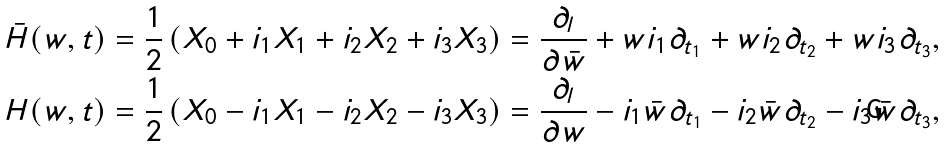<formula> <loc_0><loc_0><loc_500><loc_500>\bar { H } ( w , t ) & = \frac { 1 } { 2 } \left ( X _ { 0 } + i _ { 1 } X _ { 1 } + i _ { 2 } X _ { 2 } + i _ { 3 } X _ { 3 } \right ) = \frac { \partial _ { l } } { \partial \bar { w } } + w i _ { 1 } \partial _ { t _ { 1 } } + w i _ { 2 } \partial _ { t _ { 2 } } + w i _ { 3 } \partial _ { t _ { 3 } } , \\ H ( w , t ) & = \frac { 1 } { 2 } \left ( X _ { 0 } - i _ { 1 } X _ { 1 } - i _ { 2 } X _ { 2 } - i _ { 3 } X _ { 3 } \right ) = \frac { \partial _ { l } } { \partial w } - i _ { 1 } \bar { w } \partial _ { t _ { 1 } } - i _ { 2 } \bar { w } \partial _ { t _ { 2 } } - i _ { 3 } \bar { w } \partial _ { t _ { 3 } } ,</formula> 